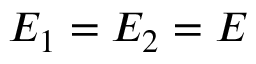Convert formula to latex. <formula><loc_0><loc_0><loc_500><loc_500>E _ { 1 } = E _ { 2 } = E</formula> 